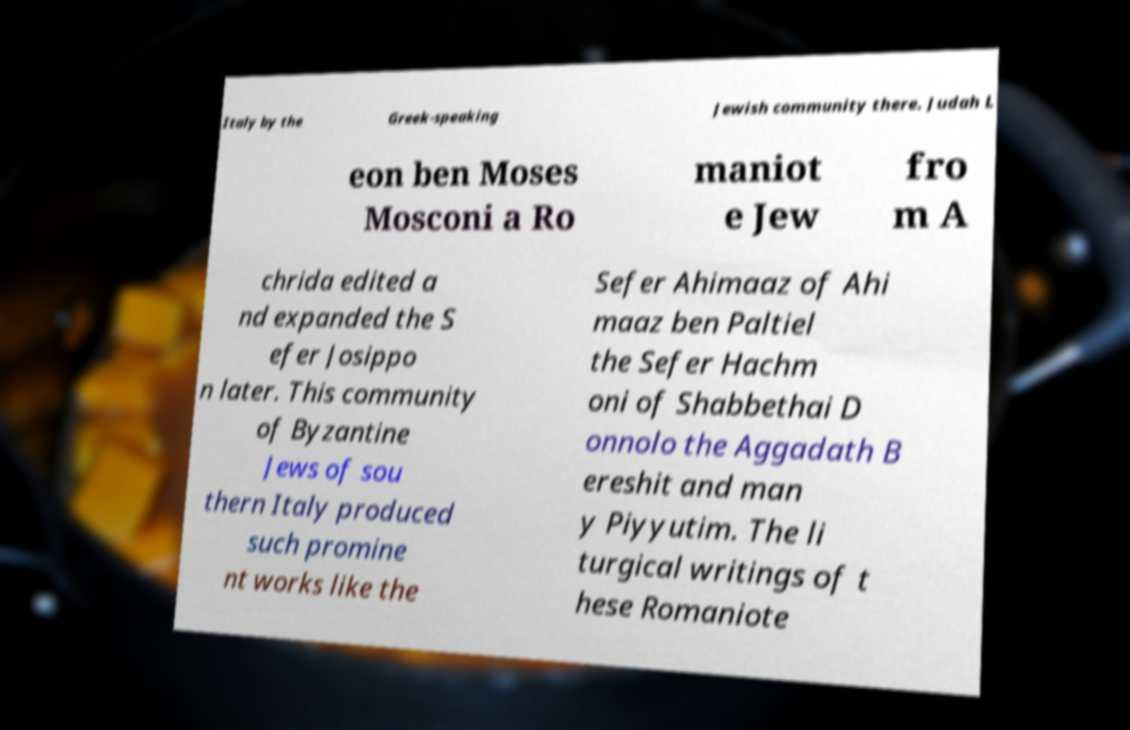I need the written content from this picture converted into text. Can you do that? Italy by the Greek-speaking Jewish community there. Judah L eon ben Moses Mosconi a Ro maniot e Jew fro m A chrida edited a nd expanded the S efer Josippo n later. This community of Byzantine Jews of sou thern Italy produced such promine nt works like the Sefer Ahimaaz of Ahi maaz ben Paltiel the Sefer Hachm oni of Shabbethai D onnolo the Aggadath B ereshit and man y Piyyutim. The li turgical writings of t hese Romaniote 